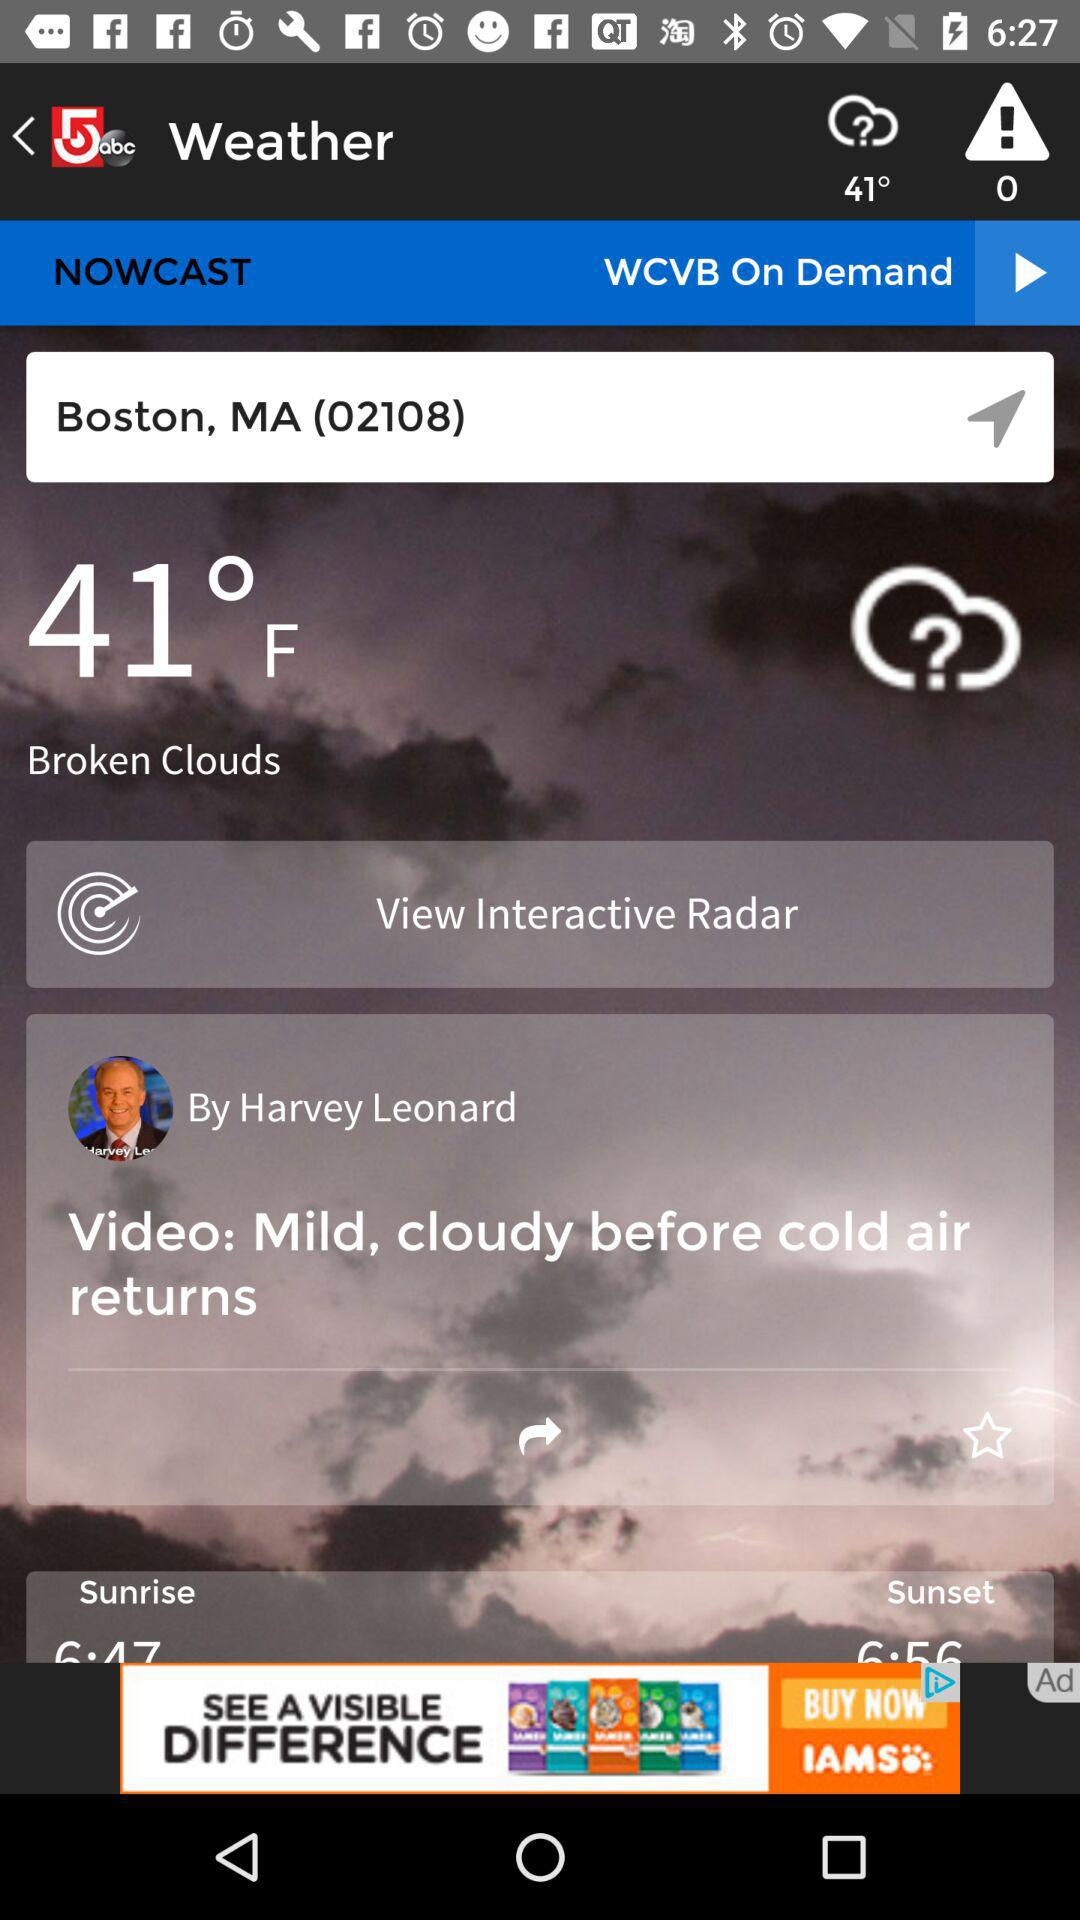What is the weather in Boston, MA?
Answer the question using a single word or phrase. The weather in Boston, MA is "Broken Clouds." 